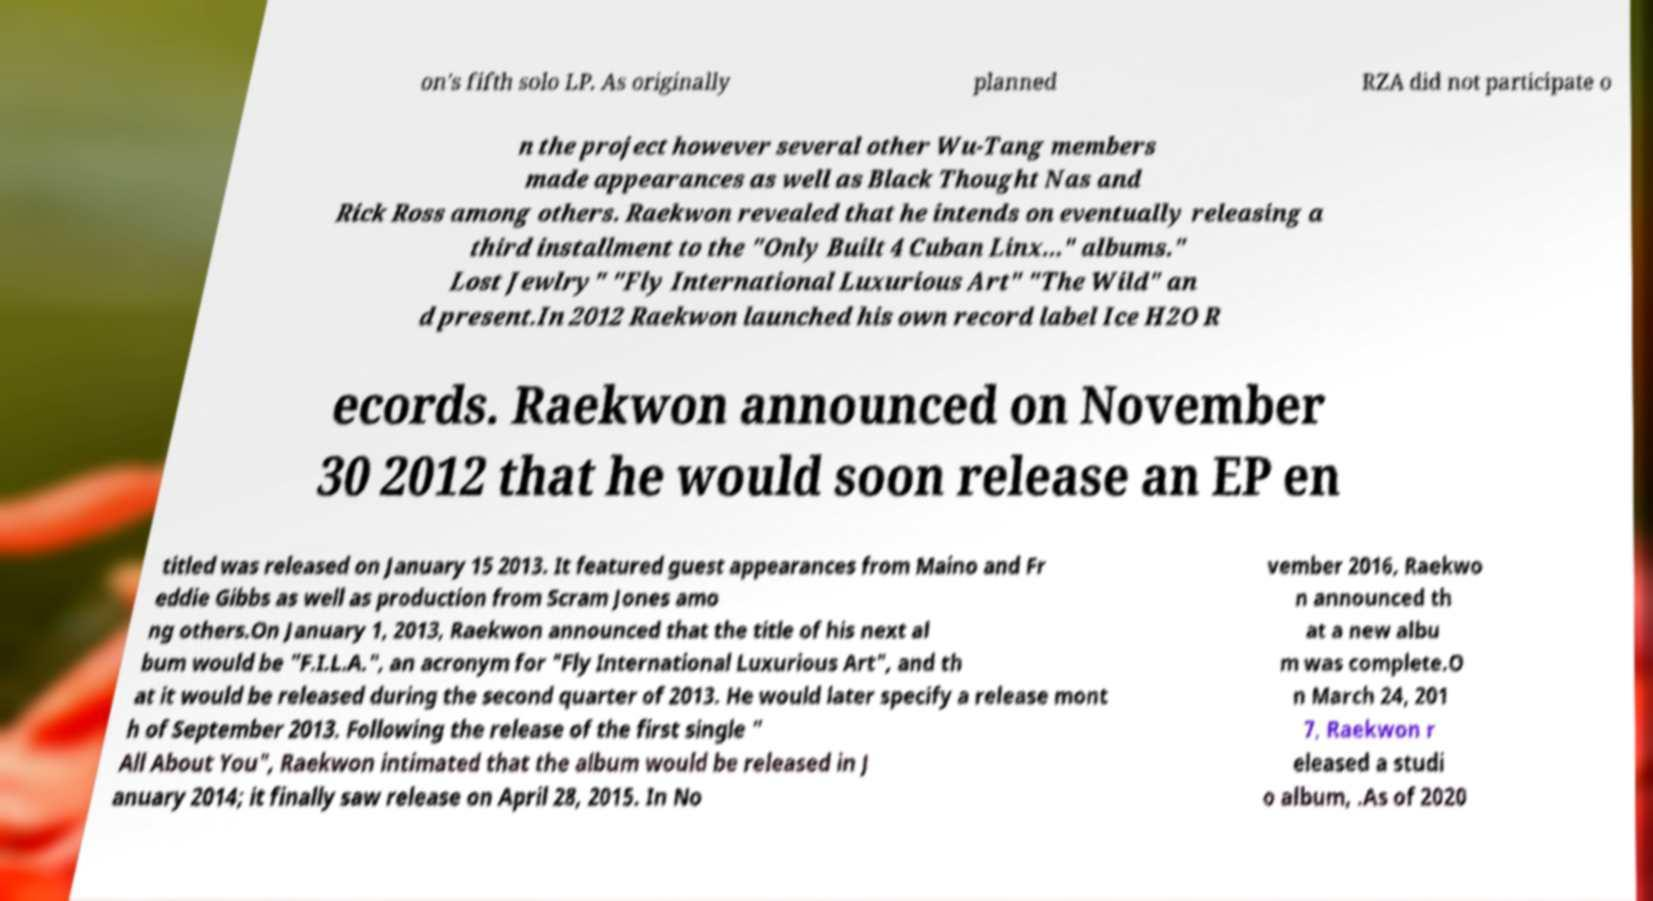What messages or text are displayed in this image? I need them in a readable, typed format. on's fifth solo LP. As originally planned RZA did not participate o n the project however several other Wu-Tang members made appearances as well as Black Thought Nas and Rick Ross among others. Raekwon revealed that he intends on eventually releasing a third installment to the "Only Built 4 Cuban Linx..." albums." Lost Jewlry" "Fly International Luxurious Art" "The Wild" an d present.In 2012 Raekwon launched his own record label Ice H2O R ecords. Raekwon announced on November 30 2012 that he would soon release an EP en titled was released on January 15 2013. It featured guest appearances from Maino and Fr eddie Gibbs as well as production from Scram Jones amo ng others.On January 1, 2013, Raekwon announced that the title of his next al bum would be "F.I.L.A.", an acronym for "Fly International Luxurious Art", and th at it would be released during the second quarter of 2013. He would later specify a release mont h of September 2013. Following the release of the first single " All About You", Raekwon intimated that the album would be released in J anuary 2014; it finally saw release on April 28, 2015. In No vember 2016, Raekwo n announced th at a new albu m was complete.O n March 24, 201 7, Raekwon r eleased a studi o album, .As of 2020 